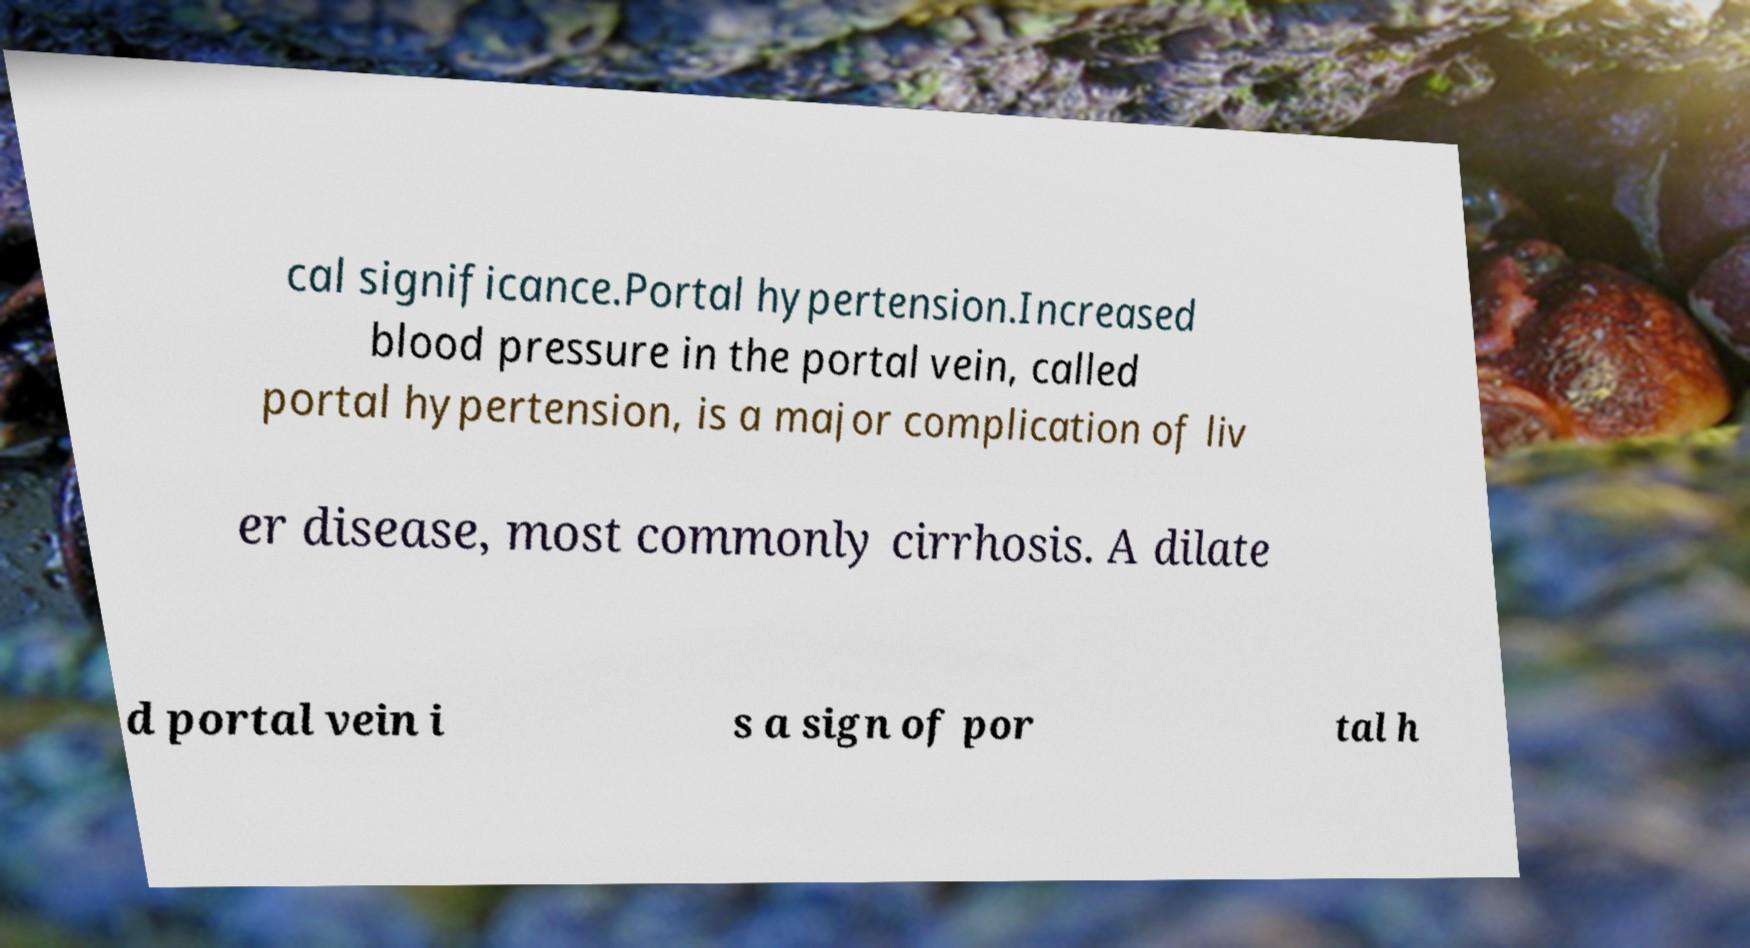There's text embedded in this image that I need extracted. Can you transcribe it verbatim? cal significance.Portal hypertension.Increased blood pressure in the portal vein, called portal hypertension, is a major complication of liv er disease, most commonly cirrhosis. A dilate d portal vein i s a sign of por tal h 